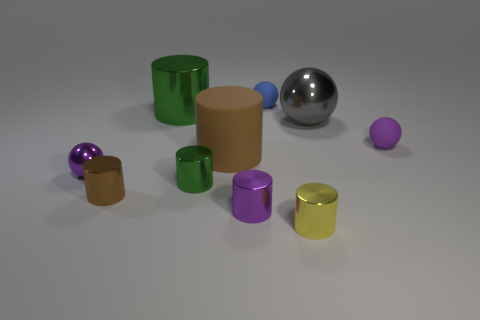There is a green thing behind the tiny purple thing right of the rubber sphere that is to the left of the tiny yellow cylinder; what is its shape?
Offer a terse response. Cylinder. What shape is the tiny metal thing that is the same color as the tiny metal ball?
Your response must be concise. Cylinder. Is there a blue shiny sphere?
Offer a very short reply. No. Does the brown matte cylinder have the same size as the purple object that is right of the large sphere?
Give a very brief answer. No. There is a purple object that is on the right side of the gray shiny sphere; is there a small purple ball that is on the right side of it?
Make the answer very short. No. The object that is both on the right side of the purple cylinder and behind the gray ball is made of what material?
Provide a short and direct response. Rubber. What color is the large cylinder that is behind the metallic ball right of the big cylinder in front of the big green metal cylinder?
Give a very brief answer. Green. What is the color of the metallic sphere that is the same size as the brown metal object?
Your answer should be very brief. Purple. There is a large rubber object; is its color the same as the small metal cylinder that is on the left side of the big green cylinder?
Offer a terse response. Yes. There is a big object in front of the tiny purple sphere to the right of the gray thing; what is it made of?
Ensure brevity in your answer.  Rubber. 